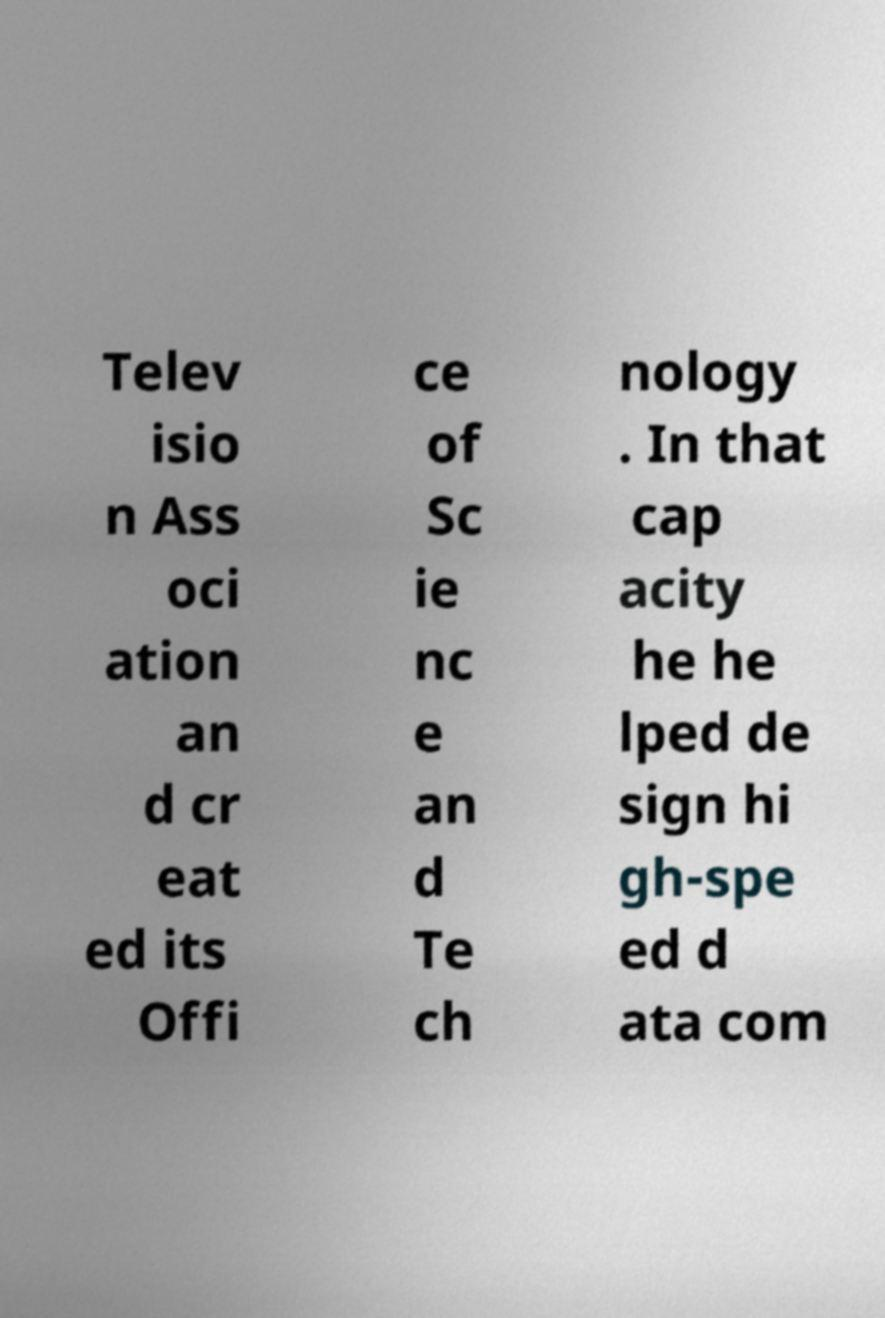Can you accurately transcribe the text from the provided image for me? Telev isio n Ass oci ation an d cr eat ed its Offi ce of Sc ie nc e an d Te ch nology . In that cap acity he he lped de sign hi gh-spe ed d ata com 